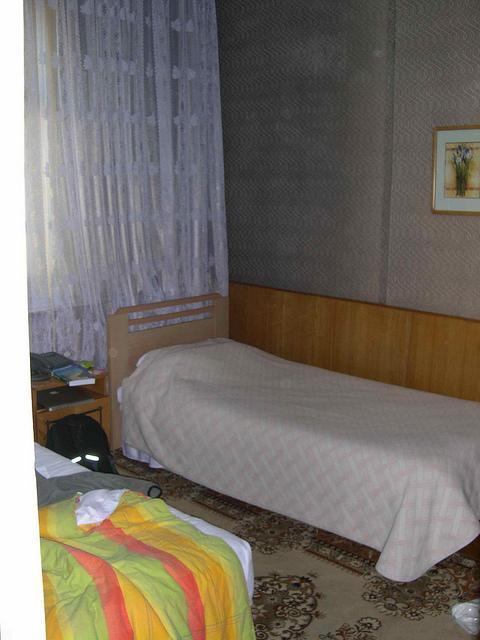How many beds are in the photo?
Give a very brief answer. 2. 